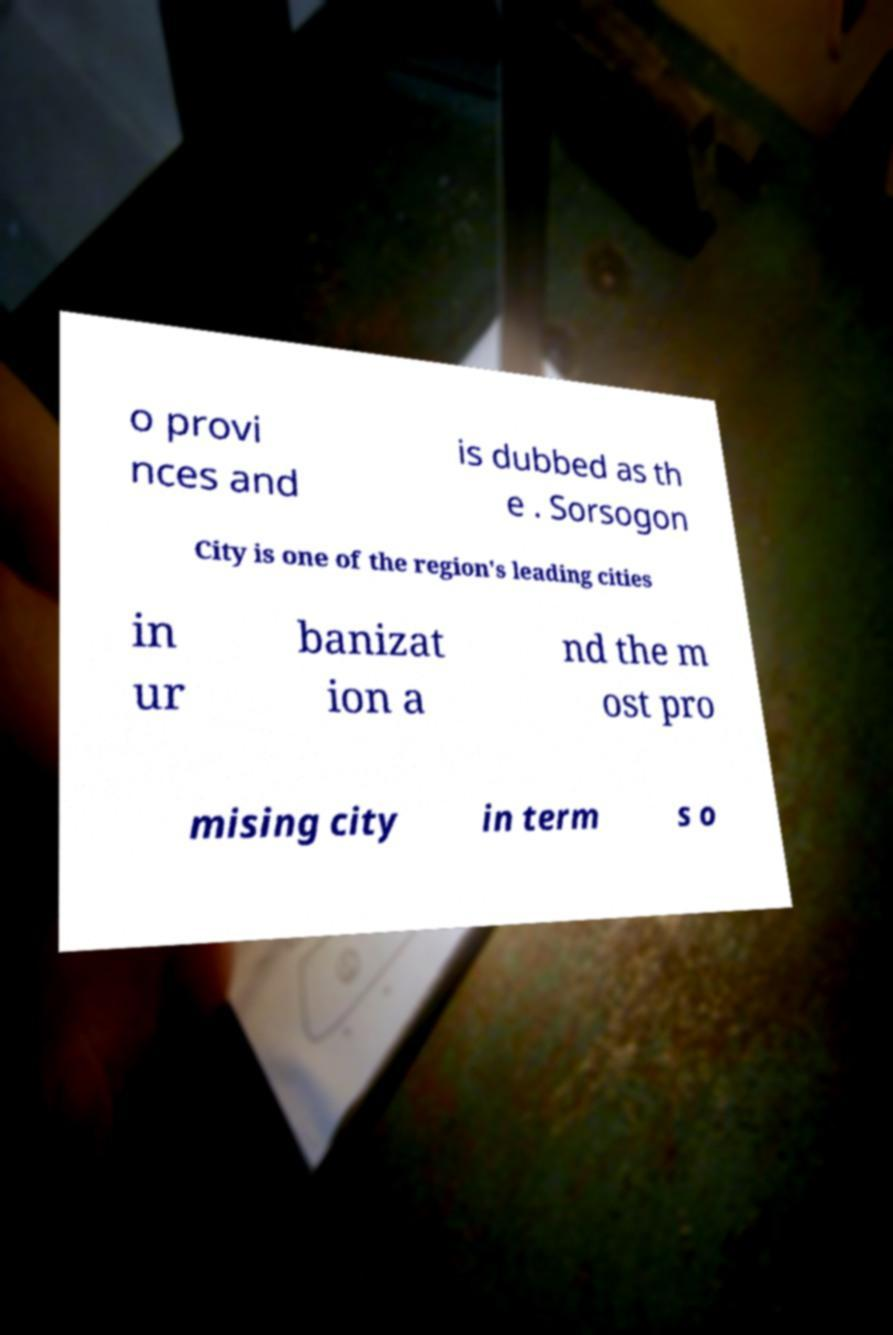Could you assist in decoding the text presented in this image and type it out clearly? o provi nces and is dubbed as th e . Sorsogon City is one of the region's leading cities in ur banizat ion a nd the m ost pro mising city in term s o 